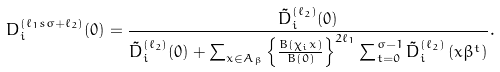<formula> <loc_0><loc_0><loc_500><loc_500>D _ { i } ^ { ( \ell _ { 1 } s \sigma + \ell _ { 2 } ) } ( 0 ) = \frac { \tilde { D } _ { i } ^ { ( \ell _ { 2 } ) } ( 0 ) } { \tilde { D } _ { i } ^ { ( \ell _ { 2 } ) } ( 0 ) + \sum _ { x \in A _ { \beta } } \left \{ \frac { B ( \chi _ { i } x ) } { B ( 0 ) } \right \} ^ { 2 \ell _ { 1 } } \sum _ { t = 0 } ^ { \sigma - 1 } \tilde { D } _ { i } ^ { ( \ell _ { 2 } ) } \left ( x \beta ^ { t } \right ) } .</formula> 